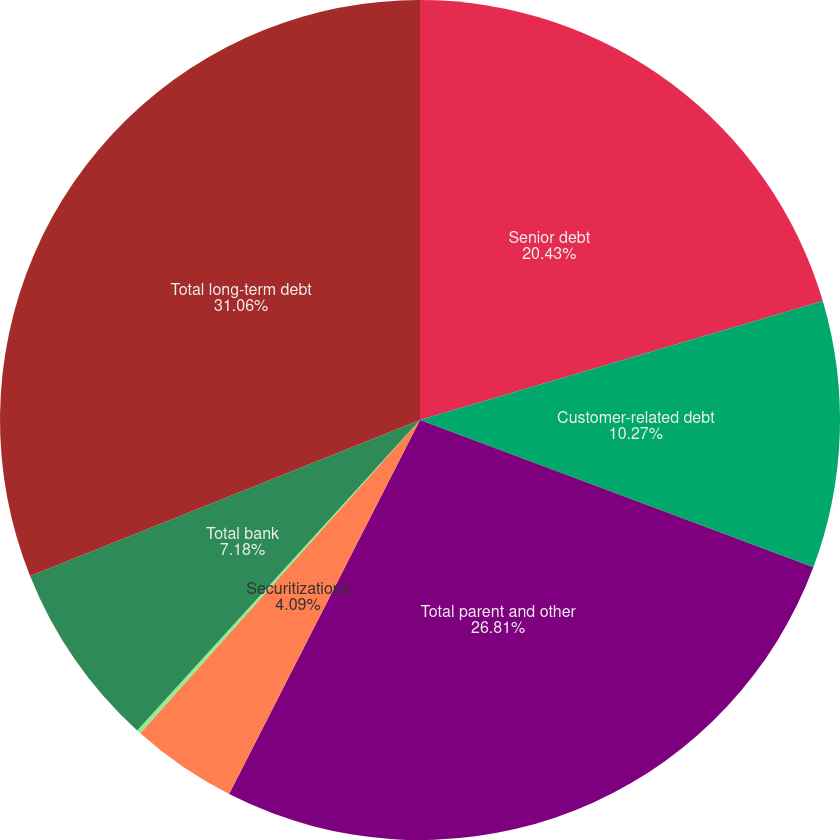Convert chart to OTSL. <chart><loc_0><loc_0><loc_500><loc_500><pie_chart><fcel>Senior debt<fcel>Customer-related debt<fcel>Total parent and other<fcel>Securitizations<fcel>Local country and other<fcel>Total bank<fcel>Total long-term debt<nl><fcel>20.43%<fcel>10.27%<fcel>26.81%<fcel>4.09%<fcel>0.16%<fcel>7.18%<fcel>31.06%<nl></chart> 